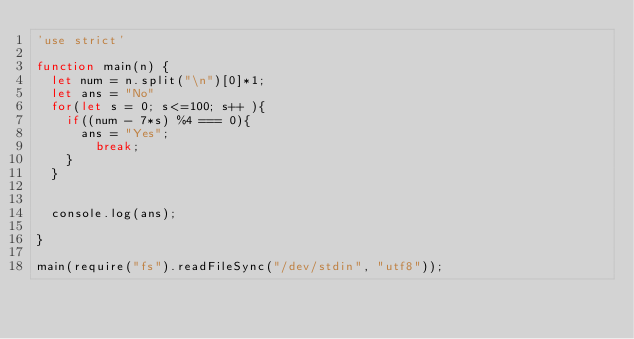Convert code to text. <code><loc_0><loc_0><loc_500><loc_500><_JavaScript_>'use strict'
 
function main(n) {
  let num = n.split("\n")[0]*1;
  let ans = "No"
  for(let s = 0; s<=100; s++ ){
    if((num - 7*s) %4 === 0){
    	ans = "Yes";
      	break;
    }
  }
  
  
  console.log(ans);
  
}
 
main(require("fs").readFileSync("/dev/stdin", "utf8"));</code> 